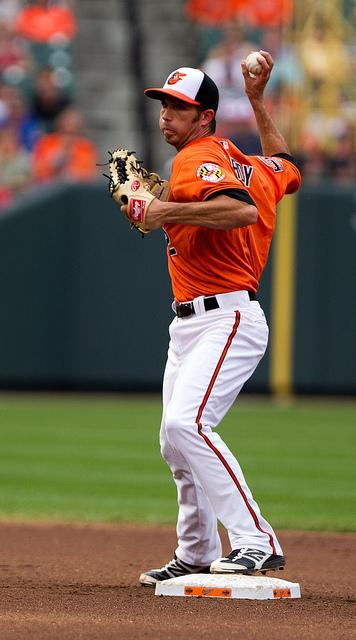What color is the man's shirt?
Keep it brief. Orange. IS this man's face tense?
Concise answer only. Yes. Is he wearing a helmet?
Concise answer only. No. 